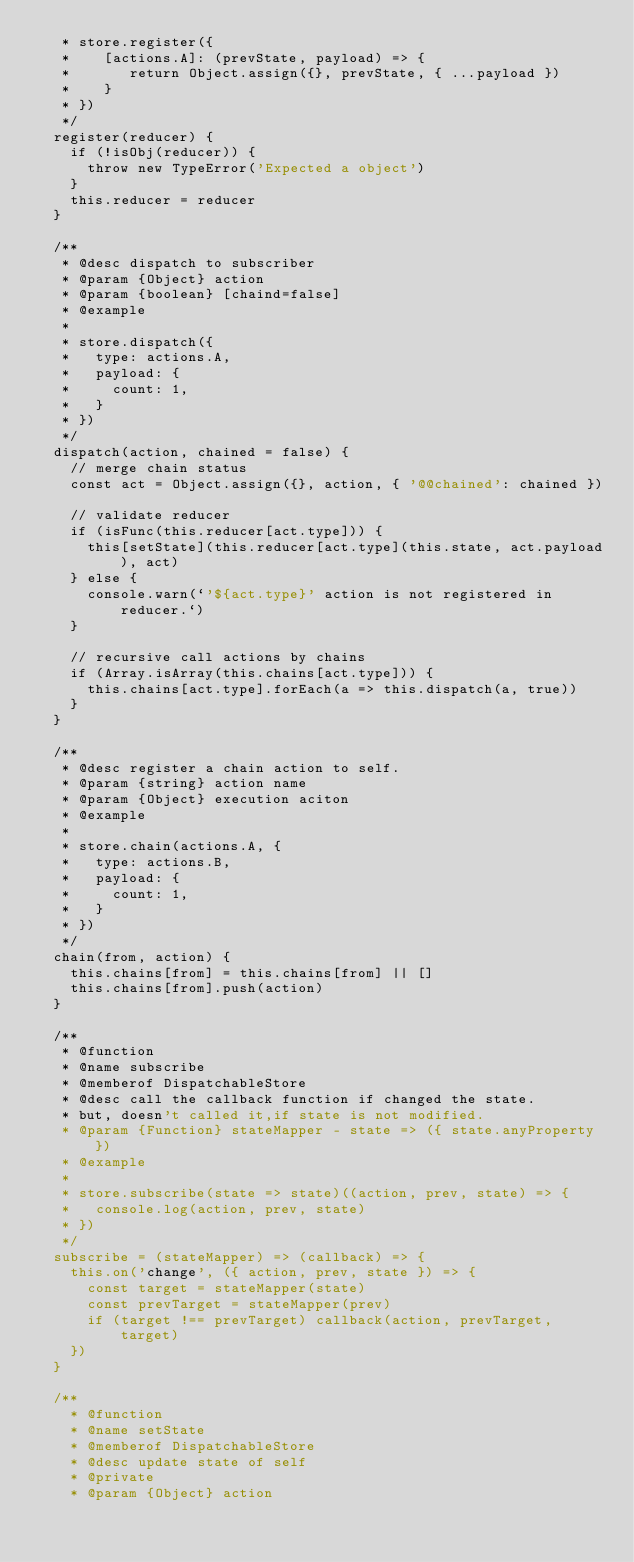Convert code to text. <code><loc_0><loc_0><loc_500><loc_500><_HTML_>   * store.register({
   *    [actions.A]: (prevState, payload) => {
   *       return Object.assign({}, prevState, { ...payload })
   *    }
   * })
   */
  register(reducer) {
    if (!isObj(reducer)) {
      throw new TypeError('Expected a object')
    }
    this.reducer = reducer
  }

  /**
   * @desc dispatch to subscriber
   * @param {Object} action
   * @param {boolean} [chaind=false]
   * @example
   *
   * store.dispatch({
   *   type: actions.A,
   *   payload: {
   *     count: 1,
   *   }
   * })
   */
  dispatch(action, chained = false) {
    // merge chain status
    const act = Object.assign({}, action, { '@@chained': chained })

    // validate reducer
    if (isFunc(this.reducer[act.type])) {
      this[setState](this.reducer[act.type](this.state, act.payload), act)
    } else {
      console.warn(`'${act.type}' action is not registered in reducer.`)
    }

    // recursive call actions by chains
    if (Array.isArray(this.chains[act.type])) {
      this.chains[act.type].forEach(a => this.dispatch(a, true))
    }
  }

  /**
   * @desc register a chain action to self.
   * @param {string} action name
   * @param {Object} execution aciton
   * @example
   *
   * store.chain(actions.A, {
   *   type: actions.B,
   *   payload: {
   *     count: 1,
   *   }
   * })
   */
  chain(from, action) {
    this.chains[from] = this.chains[from] || []
    this.chains[from].push(action)
  }

  /**
   * @function
   * @name subscribe
   * @memberof DispatchableStore
   * @desc call the callback function if changed the state.
   * but, doesn't called it,if state is not modified.
   * @param {Function} stateMapper - state => ({ state.anyProperty })
   * @example
   *
   * store.subscribe(state => state)((action, prev, state) => {
   *   console.log(action, prev, state)
   * })
   */
  subscribe = (stateMapper) => (callback) => {
    this.on('change', ({ action, prev, state }) => {
      const target = stateMapper(state)
      const prevTarget = stateMapper(prev)
      if (target !== prevTarget) callback(action, prevTarget, target)
    })
  }

  /**
    * @function
    * @name setState
    * @memberof DispatchableStore
    * @desc update state of self
    * @private
    * @param {Object} action</code> 